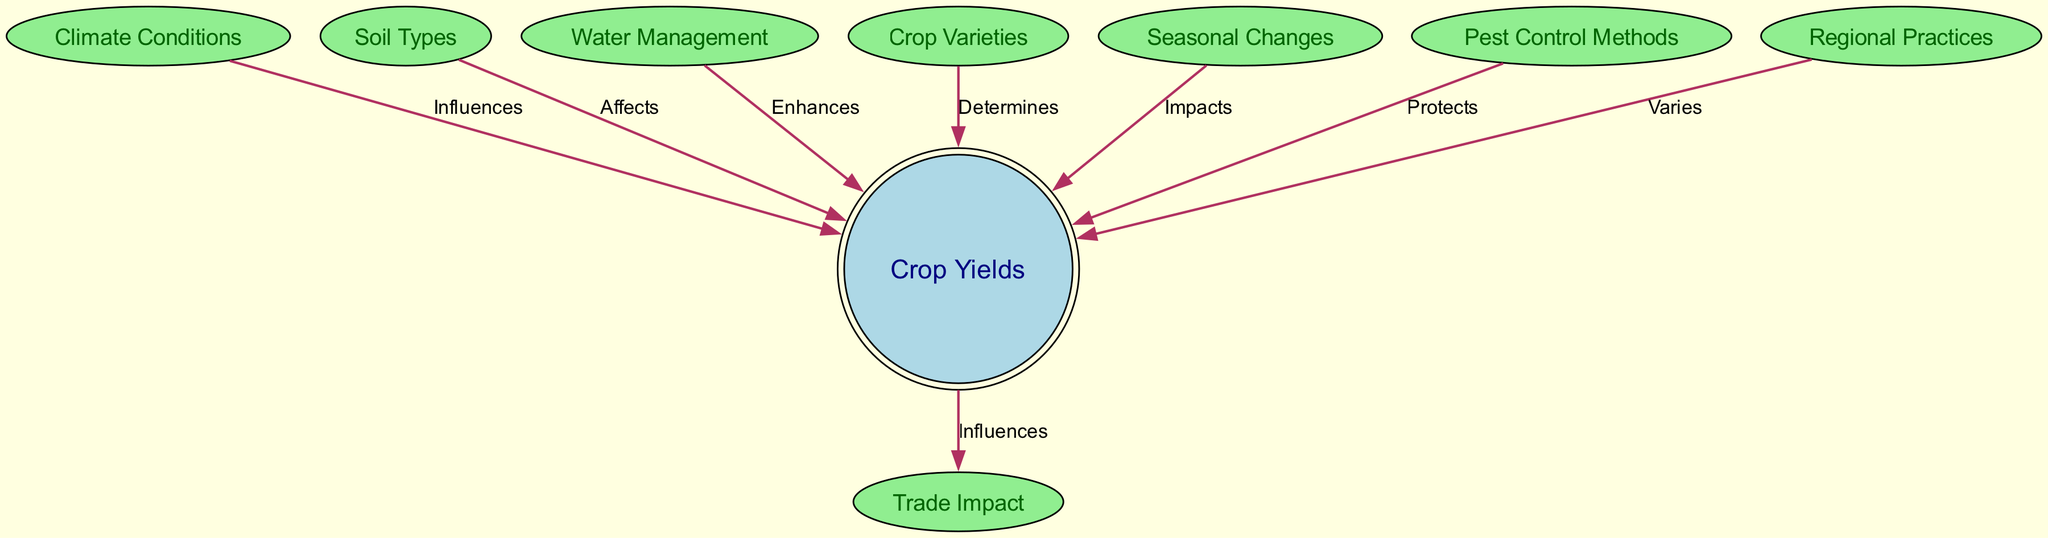What influences crop yields? The diagram shows a directed edge from "Climate Conditions" to "Crop Yields" labeled "Influences," indicating that climate conditions play a role in determining the yield of crops.
Answer: Climate Conditions How many total nodes are there in the diagram? By counting each unique node in the diagram, we find there are a total of eight distinct nodes: Climate Conditions, Soil Types, Water Management, Crop Varieties, Seasonal Changes, Pest Control Methods, Regional Practices, and Crop Yields.
Answer: Eight Which factor protects crop yields? The diagram reveals a directed edge from "Pest Control Methods" to "Crop Yields" labeled "Protects," showing that pest control methods serve to safeguard crop yields from pests.
Answer: Pest Control Methods What aspect varies among different regional practices? The diagram illustrates a directed edge from "Regional Practices" to "Crop Yields" labeled "Varies," indicating that crop yields change depending on the regional practices employed.
Answer: Regional Practices What enhances crop yields? There is an edge in the diagram from "Water Management" to "Crop Yields" with the label "Enhances," suggesting that effective water management methods contribute positively to the yield of crops.
Answer: Water Management What determines which crop varieties are grown? The edge from "Crop Varieties" to "Crop Yields" is marked as "Determines," demonstrating that the choice of crop varieties directly impacts the yields that can be produced.
Answer: Crop Varieties How do trade impacts rely on crop yields? The diagram shows that crop yields influence trade impacts ("Crop Yields" to "Trade Impact" labeled "Influences"), confirming that the yields of crops can affect the nature and extent of trade.
Answer: Crop Yields Which factors directly link to crop yields? By examining the connections in the diagram, the nodes that link directly to "Crop Yields" include Climate Conditions, Soil Types, Water Management, Crop Varieties, Seasonal Changes, Pest Control Methods, and Regional Practices, making a total of seven factors.
Answer: Seven factors 